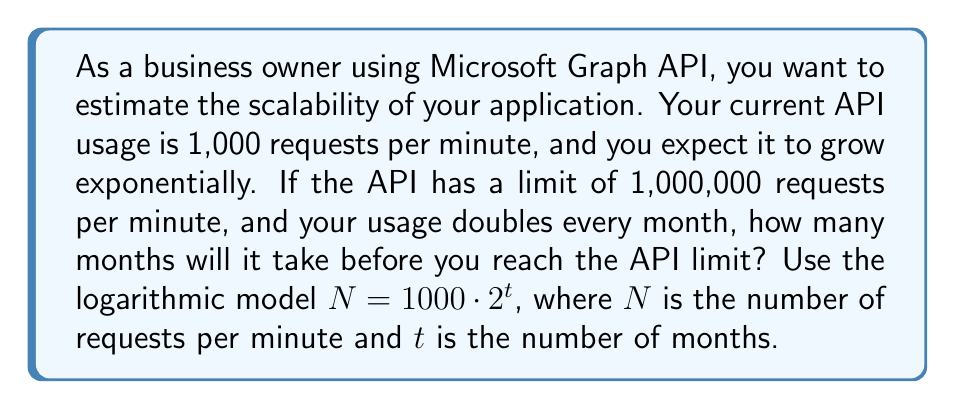Provide a solution to this math problem. To solve this problem, we'll use the logarithmic model provided and solve for $t$ when $N$ reaches the API limit.

1. Set up the equation:
   $1000000 = 1000 \cdot 2^t$

2. Divide both sides by 1000:
   $1000 = 2^t$

3. Take the logarithm (base 2) of both sides:
   $\log_2(1000) = \log_2(2^t)$

4. Simplify the right side using the logarithm property $\log_a(a^x) = x$:
   $\log_2(1000) = t$

5. Calculate $\log_2(1000)$:
   $t = \frac{\log(1000)}{\log(2)} \approx 9.97$

6. Since we can only have whole months, we round up to the nearest integer:
   $t = 10$ months
Answer: It will take 10 months before reaching the API limit of 1,000,000 requests per minute. 